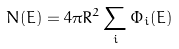Convert formula to latex. <formula><loc_0><loc_0><loc_500><loc_500>N ( E ) = 4 \pi R ^ { 2 } \sum _ { i } \Phi _ { i } ( E )</formula> 